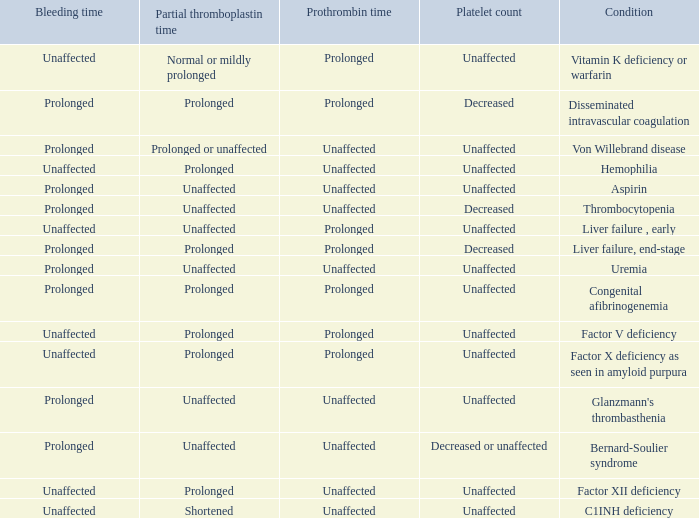Which Condition has an unaffected Prothrombin time and a Bleeding time, and a Partial thromboplastin time of prolonged? Hemophilia, Factor XII deficiency. 